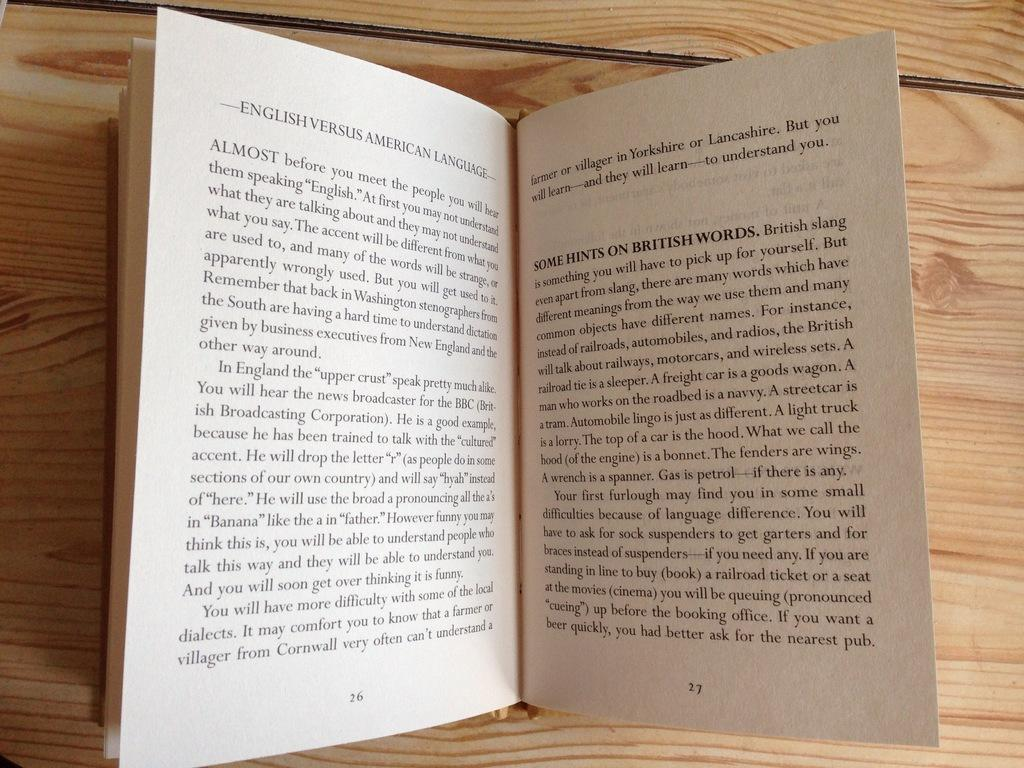Provide a one-sentence caption for the provided image. Two pages of the book English Versus American Launguage. 